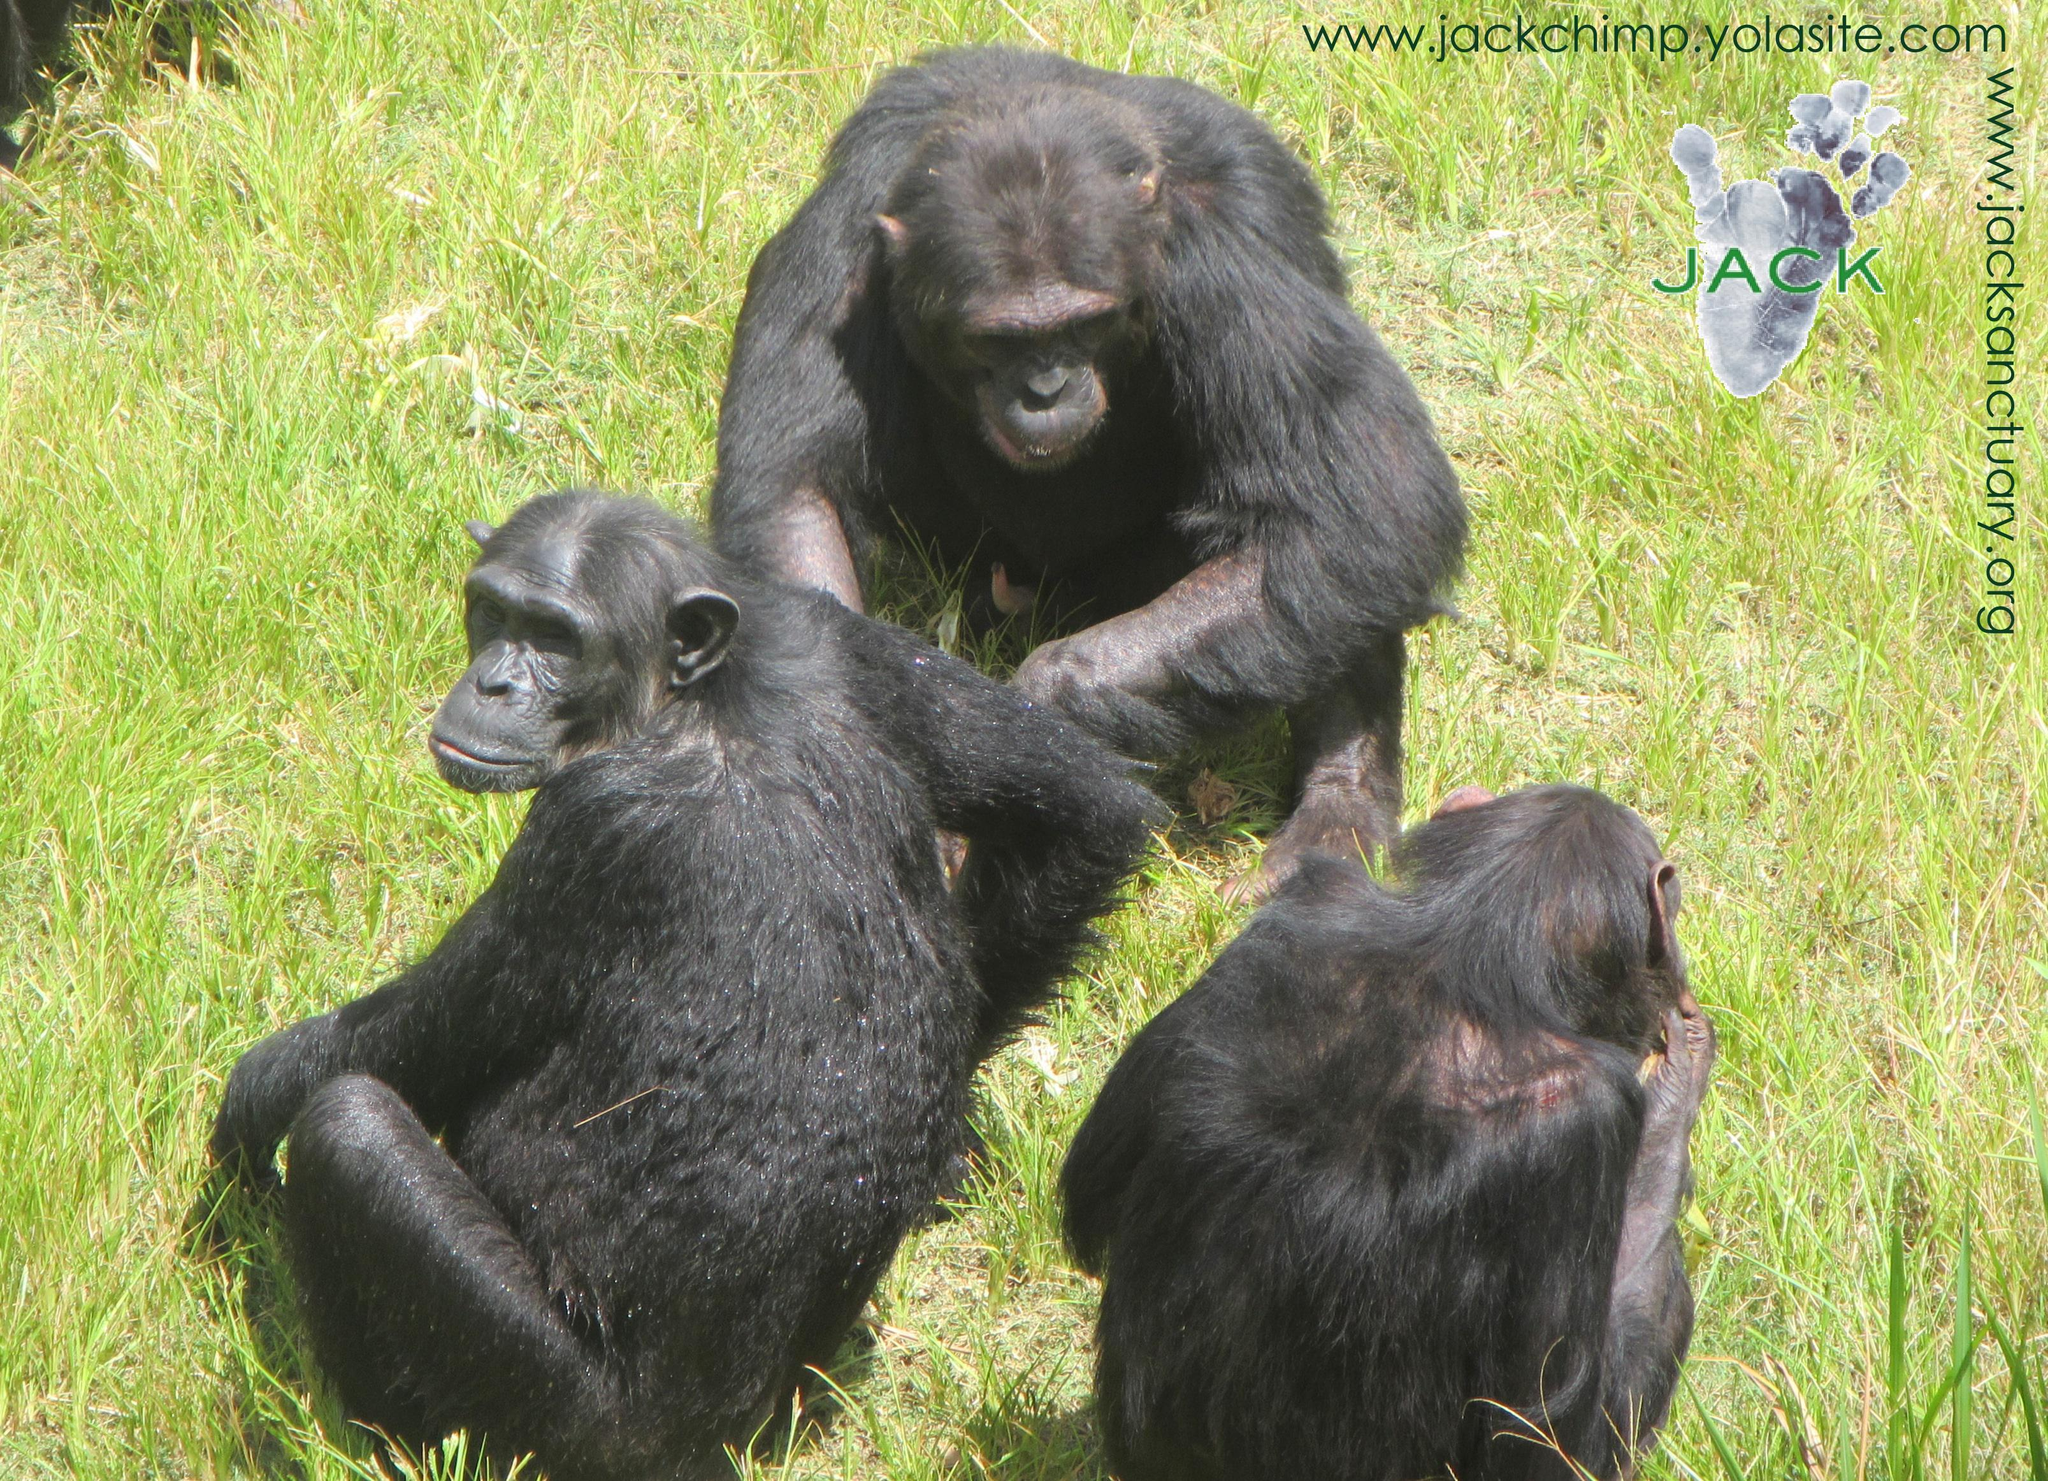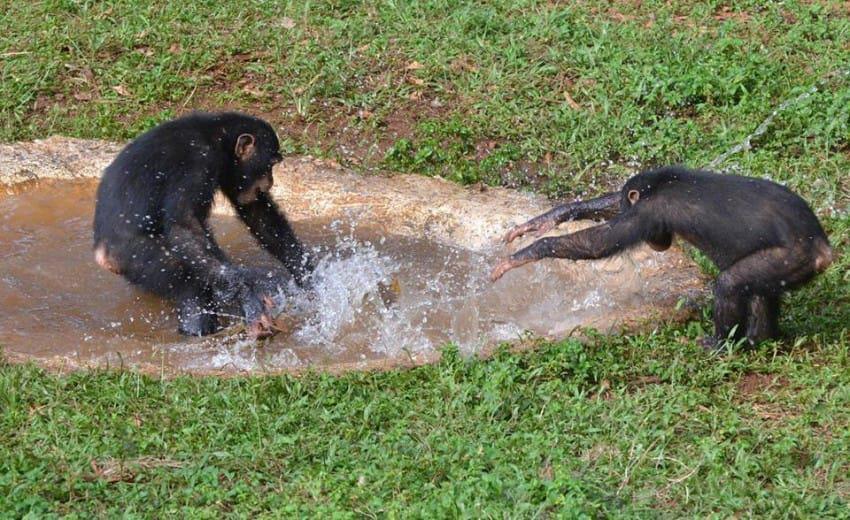The first image is the image on the left, the second image is the image on the right. For the images displayed, is the sentence "The right image contains exactly two chimpanzees." factually correct? Answer yes or no. Yes. The first image is the image on the left, the second image is the image on the right. Analyze the images presented: Is the assertion "One image shows no more than three chimps, who are near one another in a grassy field,  and the other image includes a chimp at the edge of a small pool sunken in the ground." valid? Answer yes or no. Yes. 